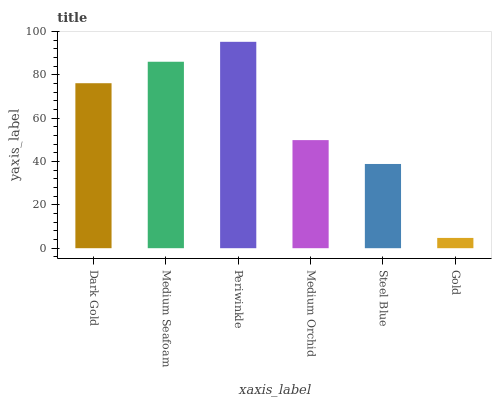Is Gold the minimum?
Answer yes or no. Yes. Is Periwinkle the maximum?
Answer yes or no. Yes. Is Medium Seafoam the minimum?
Answer yes or no. No. Is Medium Seafoam the maximum?
Answer yes or no. No. Is Medium Seafoam greater than Dark Gold?
Answer yes or no. Yes. Is Dark Gold less than Medium Seafoam?
Answer yes or no. Yes. Is Dark Gold greater than Medium Seafoam?
Answer yes or no. No. Is Medium Seafoam less than Dark Gold?
Answer yes or no. No. Is Dark Gold the high median?
Answer yes or no. Yes. Is Medium Orchid the low median?
Answer yes or no. Yes. Is Periwinkle the high median?
Answer yes or no. No. Is Periwinkle the low median?
Answer yes or no. No. 